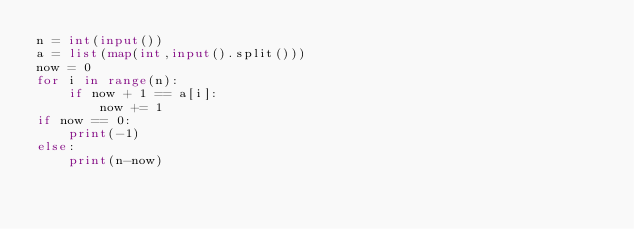Convert code to text. <code><loc_0><loc_0><loc_500><loc_500><_Python_>n = int(input())
a = list(map(int,input().split()))
now = 0
for i in range(n):
    if now + 1 == a[i]:
        now += 1
if now == 0:
    print(-1)
else:
    print(n-now)</code> 